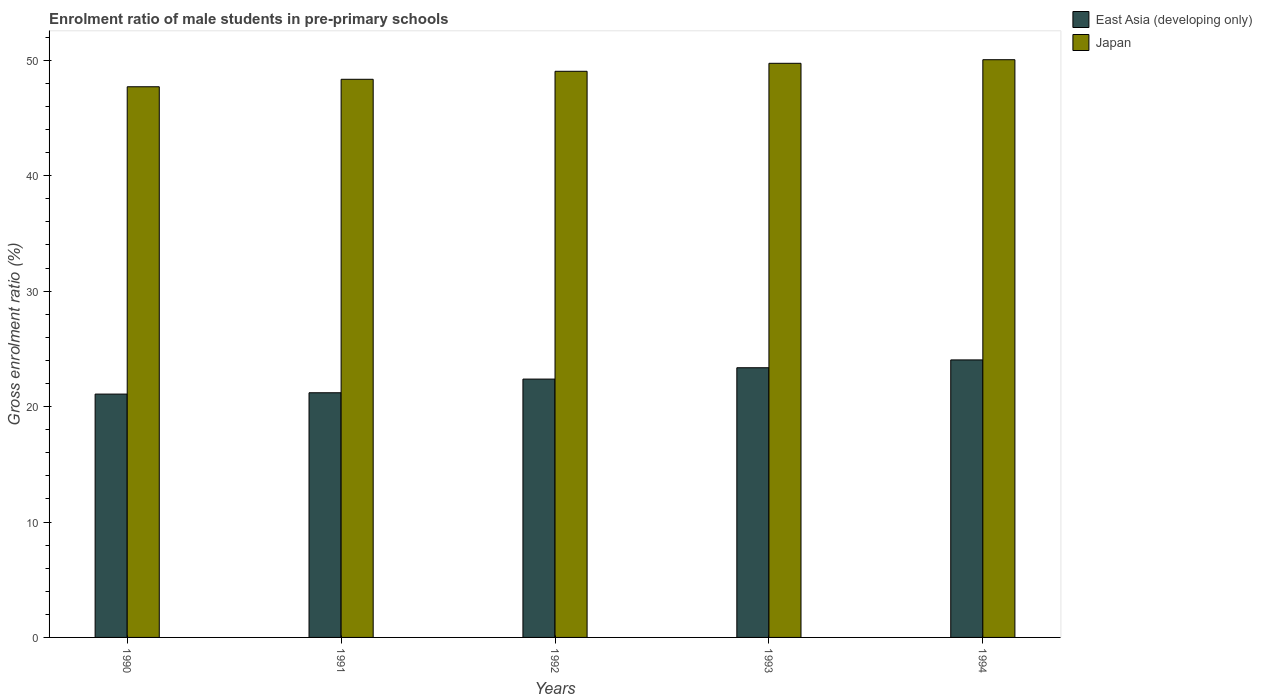How many groups of bars are there?
Provide a succinct answer. 5. Are the number of bars on each tick of the X-axis equal?
Ensure brevity in your answer.  Yes. How many bars are there on the 5th tick from the left?
Provide a succinct answer. 2. How many bars are there on the 3rd tick from the right?
Provide a succinct answer. 2. What is the label of the 1st group of bars from the left?
Offer a terse response. 1990. In how many cases, is the number of bars for a given year not equal to the number of legend labels?
Offer a very short reply. 0. What is the enrolment ratio of male students in pre-primary schools in Japan in 1991?
Provide a succinct answer. 48.35. Across all years, what is the maximum enrolment ratio of male students in pre-primary schools in East Asia (developing only)?
Your answer should be compact. 24.04. Across all years, what is the minimum enrolment ratio of male students in pre-primary schools in Japan?
Make the answer very short. 47.71. In which year was the enrolment ratio of male students in pre-primary schools in Japan minimum?
Offer a very short reply. 1990. What is the total enrolment ratio of male students in pre-primary schools in East Asia (developing only) in the graph?
Give a very brief answer. 112.07. What is the difference between the enrolment ratio of male students in pre-primary schools in East Asia (developing only) in 1991 and that in 1992?
Offer a terse response. -1.18. What is the difference between the enrolment ratio of male students in pre-primary schools in East Asia (developing only) in 1992 and the enrolment ratio of male students in pre-primary schools in Japan in 1990?
Provide a succinct answer. -25.33. What is the average enrolment ratio of male students in pre-primary schools in East Asia (developing only) per year?
Your answer should be very brief. 22.41. In the year 1992, what is the difference between the enrolment ratio of male students in pre-primary schools in Japan and enrolment ratio of male students in pre-primary schools in East Asia (developing only)?
Provide a short and direct response. 26.67. In how many years, is the enrolment ratio of male students in pre-primary schools in East Asia (developing only) greater than 6 %?
Ensure brevity in your answer.  5. What is the ratio of the enrolment ratio of male students in pre-primary schools in East Asia (developing only) in 1992 to that in 1994?
Provide a short and direct response. 0.93. Is the enrolment ratio of male students in pre-primary schools in Japan in 1991 less than that in 1993?
Give a very brief answer. Yes. Is the difference between the enrolment ratio of male students in pre-primary schools in Japan in 1990 and 1991 greater than the difference between the enrolment ratio of male students in pre-primary schools in East Asia (developing only) in 1990 and 1991?
Your answer should be very brief. No. What is the difference between the highest and the second highest enrolment ratio of male students in pre-primary schools in East Asia (developing only)?
Make the answer very short. 0.68. What is the difference between the highest and the lowest enrolment ratio of male students in pre-primary schools in Japan?
Your response must be concise. 2.34. What does the 1st bar from the left in 1994 represents?
Offer a very short reply. East Asia (developing only). How many bars are there?
Your answer should be very brief. 10. What is the difference between two consecutive major ticks on the Y-axis?
Your answer should be compact. 10. Are the values on the major ticks of Y-axis written in scientific E-notation?
Provide a short and direct response. No. Does the graph contain any zero values?
Your response must be concise. No. Where does the legend appear in the graph?
Keep it short and to the point. Top right. How are the legend labels stacked?
Offer a terse response. Vertical. What is the title of the graph?
Your response must be concise. Enrolment ratio of male students in pre-primary schools. Does "Guam" appear as one of the legend labels in the graph?
Ensure brevity in your answer.  No. What is the label or title of the X-axis?
Your response must be concise. Years. What is the label or title of the Y-axis?
Offer a very short reply. Gross enrolment ratio (%). What is the Gross enrolment ratio (%) of East Asia (developing only) in 1990?
Your answer should be compact. 21.08. What is the Gross enrolment ratio (%) in Japan in 1990?
Offer a terse response. 47.71. What is the Gross enrolment ratio (%) in East Asia (developing only) in 1991?
Give a very brief answer. 21.2. What is the Gross enrolment ratio (%) of Japan in 1991?
Provide a succinct answer. 48.35. What is the Gross enrolment ratio (%) of East Asia (developing only) in 1992?
Provide a short and direct response. 22.38. What is the Gross enrolment ratio (%) of Japan in 1992?
Offer a terse response. 49.05. What is the Gross enrolment ratio (%) in East Asia (developing only) in 1993?
Give a very brief answer. 23.36. What is the Gross enrolment ratio (%) in Japan in 1993?
Make the answer very short. 49.74. What is the Gross enrolment ratio (%) in East Asia (developing only) in 1994?
Make the answer very short. 24.04. What is the Gross enrolment ratio (%) of Japan in 1994?
Your answer should be very brief. 50.05. Across all years, what is the maximum Gross enrolment ratio (%) of East Asia (developing only)?
Your answer should be very brief. 24.04. Across all years, what is the maximum Gross enrolment ratio (%) of Japan?
Offer a terse response. 50.05. Across all years, what is the minimum Gross enrolment ratio (%) of East Asia (developing only)?
Keep it short and to the point. 21.08. Across all years, what is the minimum Gross enrolment ratio (%) of Japan?
Make the answer very short. 47.71. What is the total Gross enrolment ratio (%) in East Asia (developing only) in the graph?
Ensure brevity in your answer.  112.07. What is the total Gross enrolment ratio (%) of Japan in the graph?
Offer a very short reply. 244.9. What is the difference between the Gross enrolment ratio (%) of East Asia (developing only) in 1990 and that in 1991?
Provide a short and direct response. -0.12. What is the difference between the Gross enrolment ratio (%) in Japan in 1990 and that in 1991?
Your answer should be very brief. -0.65. What is the difference between the Gross enrolment ratio (%) in East Asia (developing only) in 1990 and that in 1992?
Your answer should be compact. -1.3. What is the difference between the Gross enrolment ratio (%) in Japan in 1990 and that in 1992?
Offer a terse response. -1.34. What is the difference between the Gross enrolment ratio (%) in East Asia (developing only) in 1990 and that in 1993?
Offer a very short reply. -2.28. What is the difference between the Gross enrolment ratio (%) in Japan in 1990 and that in 1993?
Offer a very short reply. -2.03. What is the difference between the Gross enrolment ratio (%) in East Asia (developing only) in 1990 and that in 1994?
Your response must be concise. -2.96. What is the difference between the Gross enrolment ratio (%) of Japan in 1990 and that in 1994?
Offer a very short reply. -2.34. What is the difference between the Gross enrolment ratio (%) of East Asia (developing only) in 1991 and that in 1992?
Your answer should be very brief. -1.18. What is the difference between the Gross enrolment ratio (%) of Japan in 1991 and that in 1992?
Keep it short and to the point. -0.69. What is the difference between the Gross enrolment ratio (%) in East Asia (developing only) in 1991 and that in 1993?
Your answer should be compact. -2.17. What is the difference between the Gross enrolment ratio (%) of Japan in 1991 and that in 1993?
Your answer should be compact. -1.38. What is the difference between the Gross enrolment ratio (%) of East Asia (developing only) in 1991 and that in 1994?
Offer a terse response. -2.85. What is the difference between the Gross enrolment ratio (%) in Japan in 1991 and that in 1994?
Keep it short and to the point. -1.7. What is the difference between the Gross enrolment ratio (%) of East Asia (developing only) in 1992 and that in 1993?
Offer a very short reply. -0.98. What is the difference between the Gross enrolment ratio (%) in Japan in 1992 and that in 1993?
Ensure brevity in your answer.  -0.69. What is the difference between the Gross enrolment ratio (%) in East Asia (developing only) in 1992 and that in 1994?
Make the answer very short. -1.66. What is the difference between the Gross enrolment ratio (%) in Japan in 1992 and that in 1994?
Ensure brevity in your answer.  -1. What is the difference between the Gross enrolment ratio (%) in East Asia (developing only) in 1993 and that in 1994?
Keep it short and to the point. -0.68. What is the difference between the Gross enrolment ratio (%) of Japan in 1993 and that in 1994?
Ensure brevity in your answer.  -0.31. What is the difference between the Gross enrolment ratio (%) of East Asia (developing only) in 1990 and the Gross enrolment ratio (%) of Japan in 1991?
Keep it short and to the point. -27.27. What is the difference between the Gross enrolment ratio (%) of East Asia (developing only) in 1990 and the Gross enrolment ratio (%) of Japan in 1992?
Offer a terse response. -27.97. What is the difference between the Gross enrolment ratio (%) in East Asia (developing only) in 1990 and the Gross enrolment ratio (%) in Japan in 1993?
Your answer should be very brief. -28.66. What is the difference between the Gross enrolment ratio (%) in East Asia (developing only) in 1990 and the Gross enrolment ratio (%) in Japan in 1994?
Ensure brevity in your answer.  -28.97. What is the difference between the Gross enrolment ratio (%) of East Asia (developing only) in 1991 and the Gross enrolment ratio (%) of Japan in 1992?
Offer a very short reply. -27.85. What is the difference between the Gross enrolment ratio (%) of East Asia (developing only) in 1991 and the Gross enrolment ratio (%) of Japan in 1993?
Keep it short and to the point. -28.54. What is the difference between the Gross enrolment ratio (%) in East Asia (developing only) in 1991 and the Gross enrolment ratio (%) in Japan in 1994?
Keep it short and to the point. -28.85. What is the difference between the Gross enrolment ratio (%) of East Asia (developing only) in 1992 and the Gross enrolment ratio (%) of Japan in 1993?
Offer a very short reply. -27.36. What is the difference between the Gross enrolment ratio (%) of East Asia (developing only) in 1992 and the Gross enrolment ratio (%) of Japan in 1994?
Ensure brevity in your answer.  -27.67. What is the difference between the Gross enrolment ratio (%) in East Asia (developing only) in 1993 and the Gross enrolment ratio (%) in Japan in 1994?
Offer a terse response. -26.69. What is the average Gross enrolment ratio (%) in East Asia (developing only) per year?
Your answer should be compact. 22.41. What is the average Gross enrolment ratio (%) of Japan per year?
Your response must be concise. 48.98. In the year 1990, what is the difference between the Gross enrolment ratio (%) of East Asia (developing only) and Gross enrolment ratio (%) of Japan?
Your answer should be very brief. -26.63. In the year 1991, what is the difference between the Gross enrolment ratio (%) in East Asia (developing only) and Gross enrolment ratio (%) in Japan?
Your answer should be very brief. -27.16. In the year 1992, what is the difference between the Gross enrolment ratio (%) in East Asia (developing only) and Gross enrolment ratio (%) in Japan?
Give a very brief answer. -26.67. In the year 1993, what is the difference between the Gross enrolment ratio (%) in East Asia (developing only) and Gross enrolment ratio (%) in Japan?
Your answer should be compact. -26.37. In the year 1994, what is the difference between the Gross enrolment ratio (%) in East Asia (developing only) and Gross enrolment ratio (%) in Japan?
Make the answer very short. -26.01. What is the ratio of the Gross enrolment ratio (%) in Japan in 1990 to that in 1991?
Your answer should be compact. 0.99. What is the ratio of the Gross enrolment ratio (%) in East Asia (developing only) in 1990 to that in 1992?
Provide a short and direct response. 0.94. What is the ratio of the Gross enrolment ratio (%) in Japan in 1990 to that in 1992?
Offer a very short reply. 0.97. What is the ratio of the Gross enrolment ratio (%) of East Asia (developing only) in 1990 to that in 1993?
Offer a terse response. 0.9. What is the ratio of the Gross enrolment ratio (%) in Japan in 1990 to that in 1993?
Make the answer very short. 0.96. What is the ratio of the Gross enrolment ratio (%) of East Asia (developing only) in 1990 to that in 1994?
Your response must be concise. 0.88. What is the ratio of the Gross enrolment ratio (%) in Japan in 1990 to that in 1994?
Give a very brief answer. 0.95. What is the ratio of the Gross enrolment ratio (%) of East Asia (developing only) in 1991 to that in 1992?
Keep it short and to the point. 0.95. What is the ratio of the Gross enrolment ratio (%) of Japan in 1991 to that in 1992?
Keep it short and to the point. 0.99. What is the ratio of the Gross enrolment ratio (%) in East Asia (developing only) in 1991 to that in 1993?
Your response must be concise. 0.91. What is the ratio of the Gross enrolment ratio (%) of Japan in 1991 to that in 1993?
Offer a very short reply. 0.97. What is the ratio of the Gross enrolment ratio (%) of East Asia (developing only) in 1991 to that in 1994?
Ensure brevity in your answer.  0.88. What is the ratio of the Gross enrolment ratio (%) of Japan in 1991 to that in 1994?
Your response must be concise. 0.97. What is the ratio of the Gross enrolment ratio (%) of East Asia (developing only) in 1992 to that in 1993?
Your answer should be compact. 0.96. What is the ratio of the Gross enrolment ratio (%) of Japan in 1992 to that in 1993?
Offer a terse response. 0.99. What is the ratio of the Gross enrolment ratio (%) in East Asia (developing only) in 1992 to that in 1994?
Give a very brief answer. 0.93. What is the ratio of the Gross enrolment ratio (%) of Japan in 1992 to that in 1994?
Make the answer very short. 0.98. What is the ratio of the Gross enrolment ratio (%) in East Asia (developing only) in 1993 to that in 1994?
Offer a terse response. 0.97. What is the ratio of the Gross enrolment ratio (%) in Japan in 1993 to that in 1994?
Offer a very short reply. 0.99. What is the difference between the highest and the second highest Gross enrolment ratio (%) in East Asia (developing only)?
Ensure brevity in your answer.  0.68. What is the difference between the highest and the second highest Gross enrolment ratio (%) of Japan?
Your response must be concise. 0.31. What is the difference between the highest and the lowest Gross enrolment ratio (%) of East Asia (developing only)?
Ensure brevity in your answer.  2.96. What is the difference between the highest and the lowest Gross enrolment ratio (%) of Japan?
Provide a succinct answer. 2.34. 